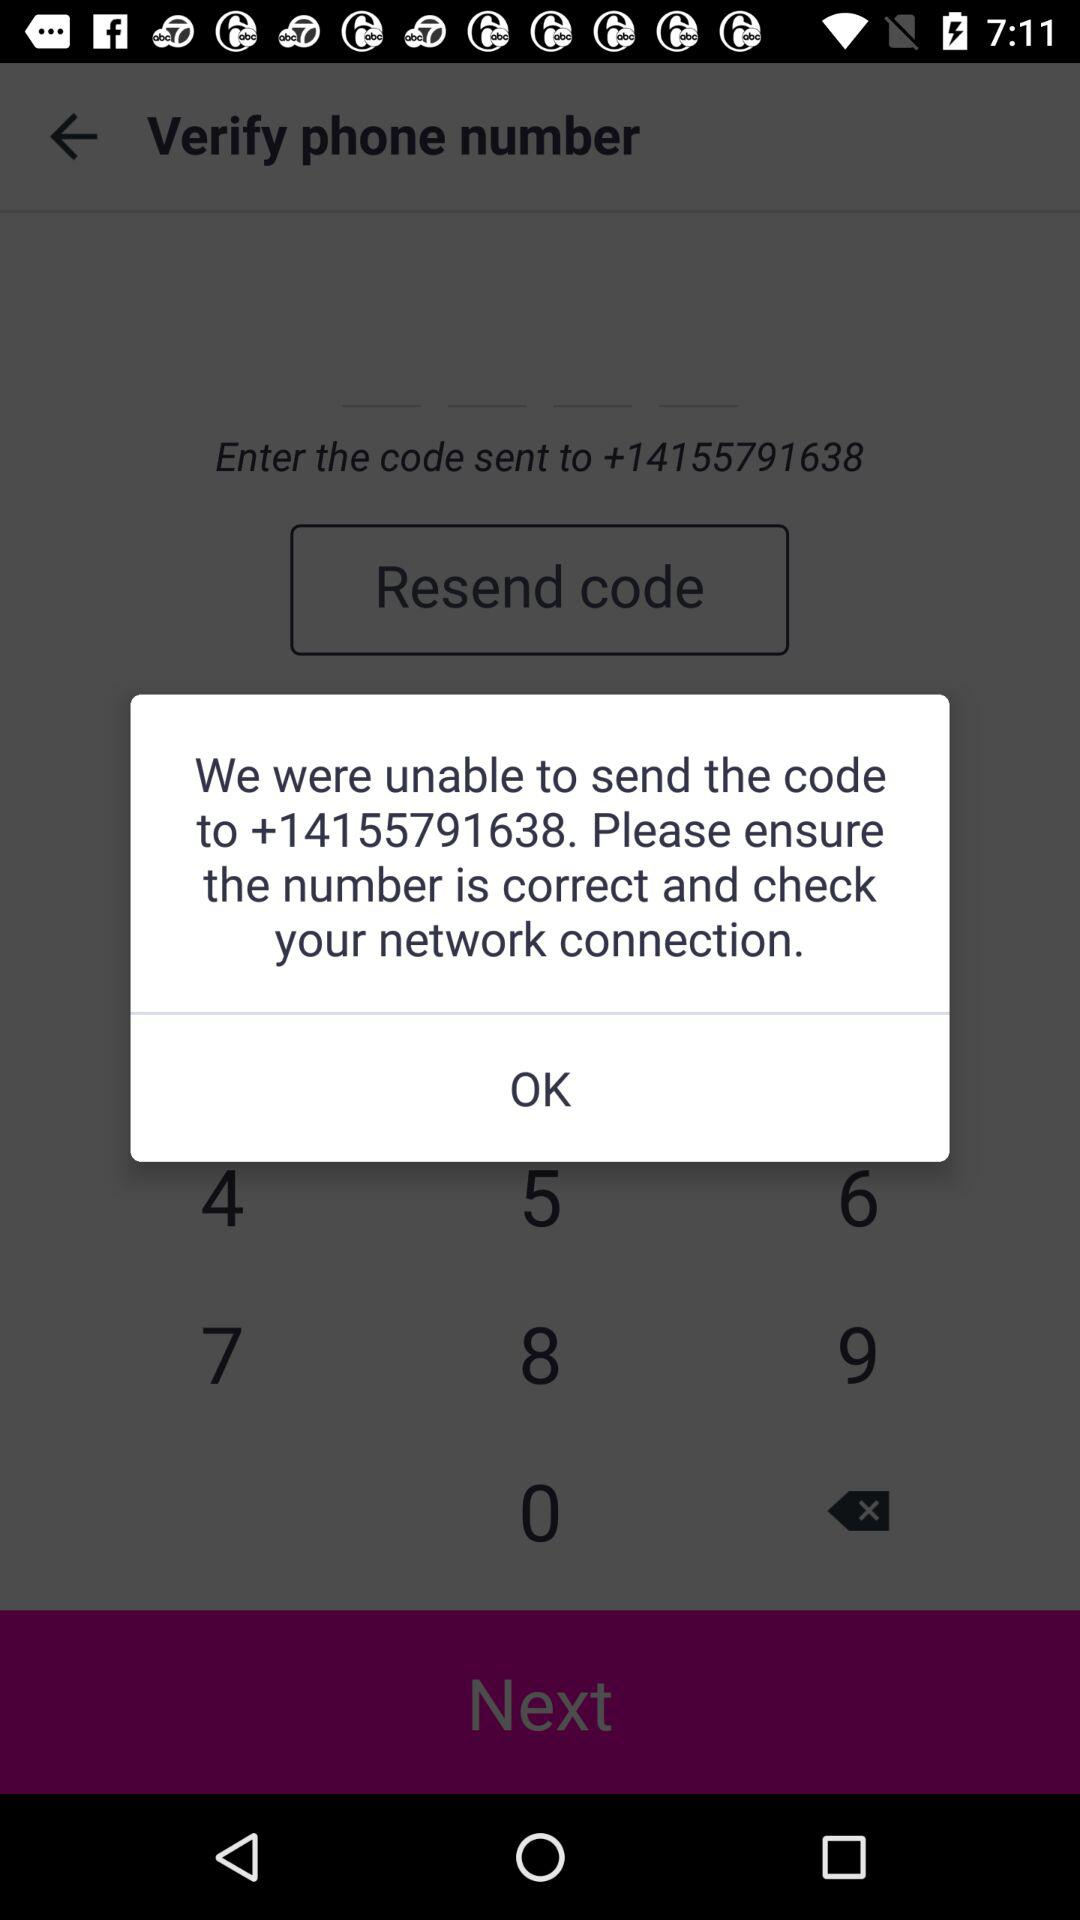On what number were they unable to send the code? They were unable to send the code to +14155791638. 